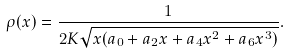Convert formula to latex. <formula><loc_0><loc_0><loc_500><loc_500>\rho ( x ) = \frac { 1 } { 2 K \sqrt { x ( a _ { 0 } + a _ { 2 } x + a _ { 4 } x ^ { 2 } + a _ { 6 } x ^ { 3 } ) } } .</formula> 